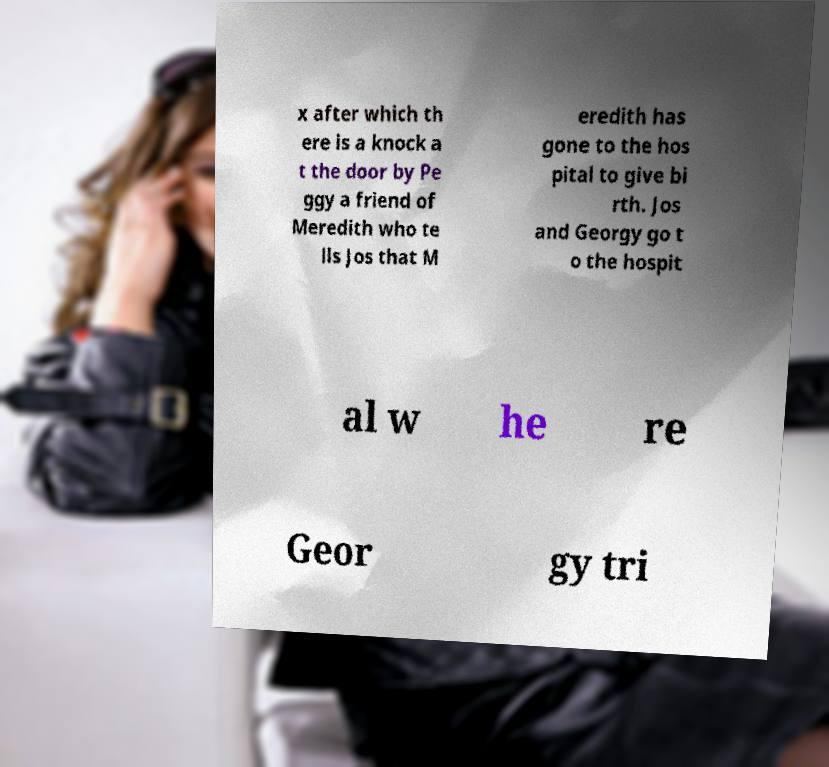Can you read and provide the text displayed in the image?This photo seems to have some interesting text. Can you extract and type it out for me? x after which th ere is a knock a t the door by Pe ggy a friend of Meredith who te lls Jos that M eredith has gone to the hos pital to give bi rth. Jos and Georgy go t o the hospit al w he re Geor gy tri 